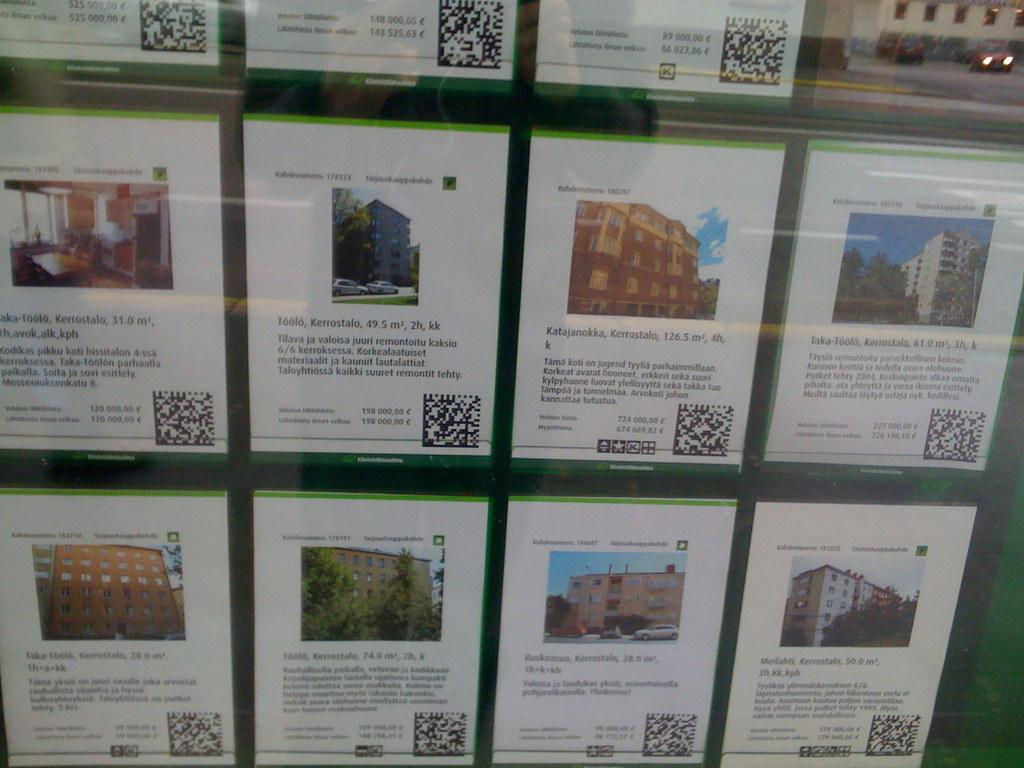<image>
Offer a succinct explanation of the picture presented. Small information signs feature facts about places like Kerrostalo and Katajanokka. 